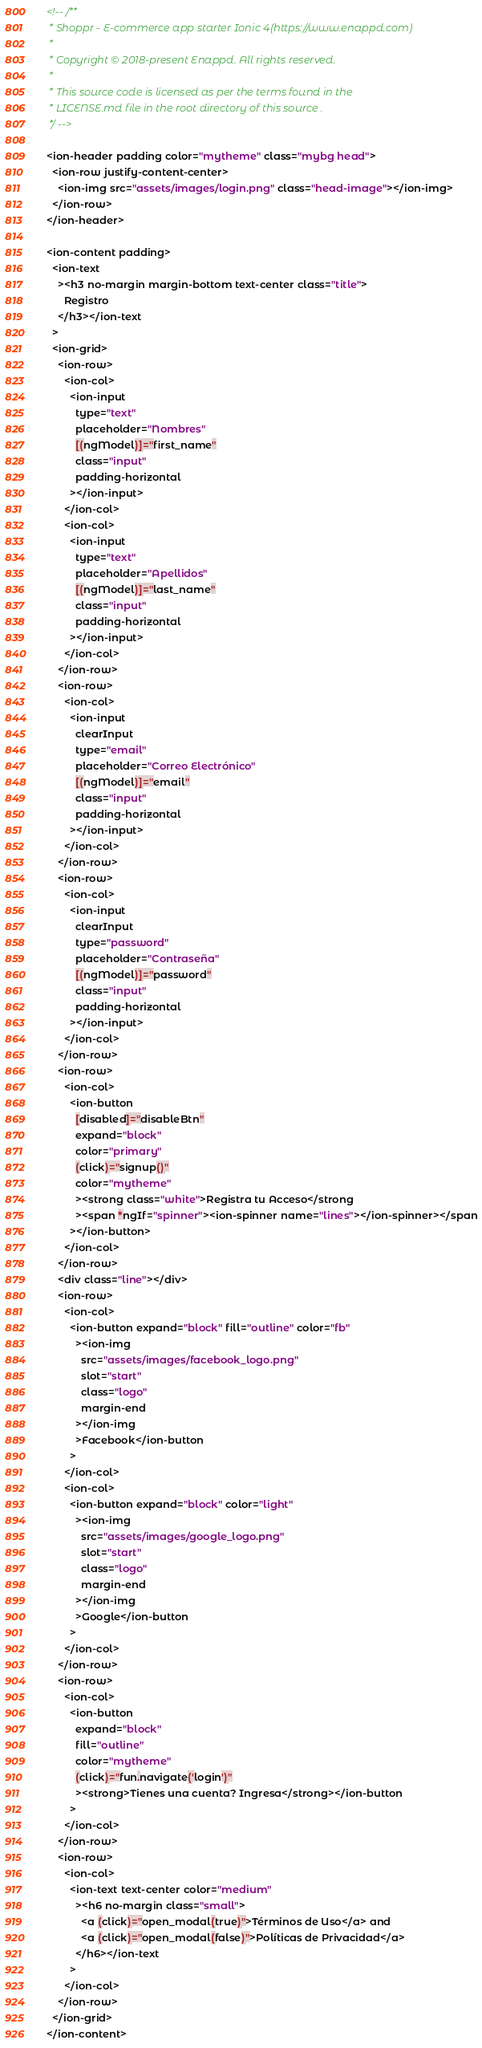Convert code to text. <code><loc_0><loc_0><loc_500><loc_500><_HTML_><!-- /**
 * Shoppr - E-commerce app starter Ionic 4(https://www.enappd.com)
 *
 * Copyright © 2018-present Enappd. All rights reserved.
 *
 * This source code is licensed as per the terms found in the
 * LICENSE.md file in the root directory of this source .
 */ -->

<ion-header padding color="mytheme" class="mybg head">
  <ion-row justify-content-center>
    <ion-img src="assets/images/login.png" class="head-image"></ion-img>
  </ion-row>
</ion-header>

<ion-content padding>
  <ion-text
    ><h3 no-margin margin-bottom text-center class="title">
      Registro
    </h3></ion-text
  >
  <ion-grid>
    <ion-row>
      <ion-col>
        <ion-input
          type="text"
          placeholder="Nombres"
          [(ngModel)]="first_name"
          class="input"
          padding-horizontal
        ></ion-input>
      </ion-col>
      <ion-col>
        <ion-input
          type="text"
          placeholder="Apellidos"
          [(ngModel)]="last_name"
          class="input"
          padding-horizontal
        ></ion-input>
      </ion-col>
    </ion-row>
    <ion-row>
      <ion-col>
        <ion-input
          clearInput
          type="email"
          placeholder="Correo Electrónico"
          [(ngModel)]="email"
          class="input"
          padding-horizontal
        ></ion-input>
      </ion-col>
    </ion-row>
    <ion-row>
      <ion-col>
        <ion-input
          clearInput
          type="password"
          placeholder="Contraseña"
          [(ngModel)]="password"
          class="input"
          padding-horizontal
        ></ion-input>
      </ion-col>
    </ion-row>
    <ion-row>
      <ion-col>
        <ion-button
          [disabled]="disableBtn"
          expand="block"
          color="primary"
          (click)="signup()"
          color="mytheme"
          ><strong class="white">Registra tu Acceso</strong
          ><span *ngIf="spinner"><ion-spinner name="lines"></ion-spinner></span
        ></ion-button>
      </ion-col>
    </ion-row>
    <div class="line"></div>
    <ion-row>
      <ion-col>
        <ion-button expand="block" fill="outline" color="fb"
          ><ion-img
            src="assets/images/facebook_logo.png"
            slot="start"
            class="logo"
            margin-end
          ></ion-img
          >Facebook</ion-button
        >
      </ion-col>
      <ion-col>
        <ion-button expand="block" color="light"
          ><ion-img
            src="assets/images/google_logo.png"
            slot="start"
            class="logo"
            margin-end
          ></ion-img
          >Google</ion-button
        >
      </ion-col>
    </ion-row>
    <ion-row>
      <ion-col>
        <ion-button
          expand="block"
          fill="outline"
          color="mytheme"
          (click)="fun.navigate('login')"
          ><strong>Tienes una cuenta? Ingresa</strong></ion-button
        >
      </ion-col>
    </ion-row>
    <ion-row>
      <ion-col>
        <ion-text text-center color="medium"
          ><h6 no-margin class="small">
            <a (click)="open_modal(true)">Términos de Uso</a> and
            <a (click)="open_modal(false)">Políticas de Privacidad</a>
          </h6></ion-text
        >
      </ion-col>
    </ion-row>
  </ion-grid>
</ion-content>
</code> 